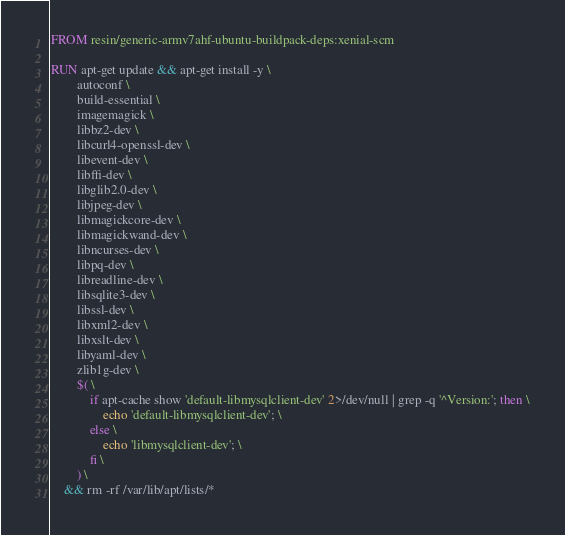<code> <loc_0><loc_0><loc_500><loc_500><_Dockerfile_>FROM resin/generic-armv7ahf-ubuntu-buildpack-deps:xenial-scm

RUN apt-get update && apt-get install -y \
		autoconf \
		build-essential \
		imagemagick \
		libbz2-dev \
		libcurl4-openssl-dev \
		libevent-dev \
		libffi-dev \
		libglib2.0-dev \
		libjpeg-dev \
		libmagickcore-dev \
		libmagickwand-dev \
		libncurses-dev \
		libpq-dev \
		libreadline-dev \
		libsqlite3-dev \
		libssl-dev \
		libxml2-dev \
		libxslt-dev \
		libyaml-dev \
		zlib1g-dev \
		$( \
			if apt-cache show 'default-libmysqlclient-dev' 2>/dev/null | grep -q '^Version:'; then \
				echo 'default-libmysqlclient-dev'; \
			else \
				echo 'libmysqlclient-dev'; \
			fi \
		) \
	&& rm -rf /var/lib/apt/lists/*
</code> 